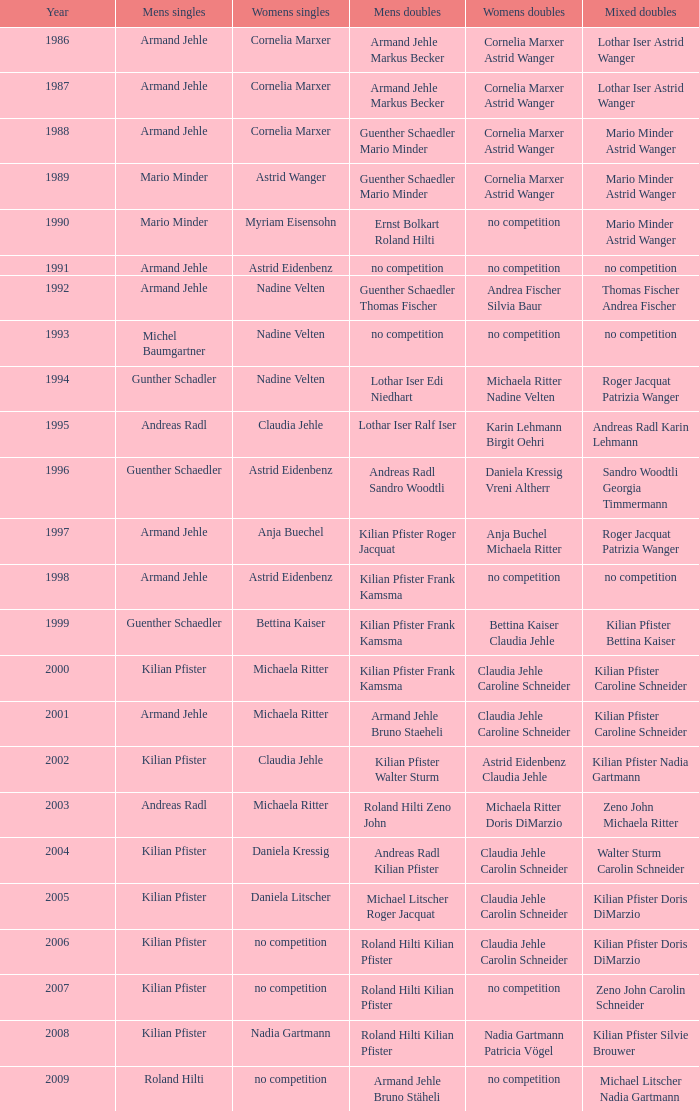In which up-to-date year did astrid eidenbenz and claudia jehle win the women's doubles championship? 2002.0. 